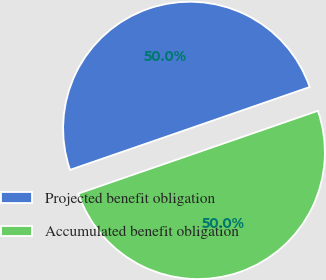<chart> <loc_0><loc_0><loc_500><loc_500><pie_chart><fcel>Projected benefit obligation<fcel>Accumulated benefit obligation<nl><fcel>49.98%<fcel>50.02%<nl></chart> 